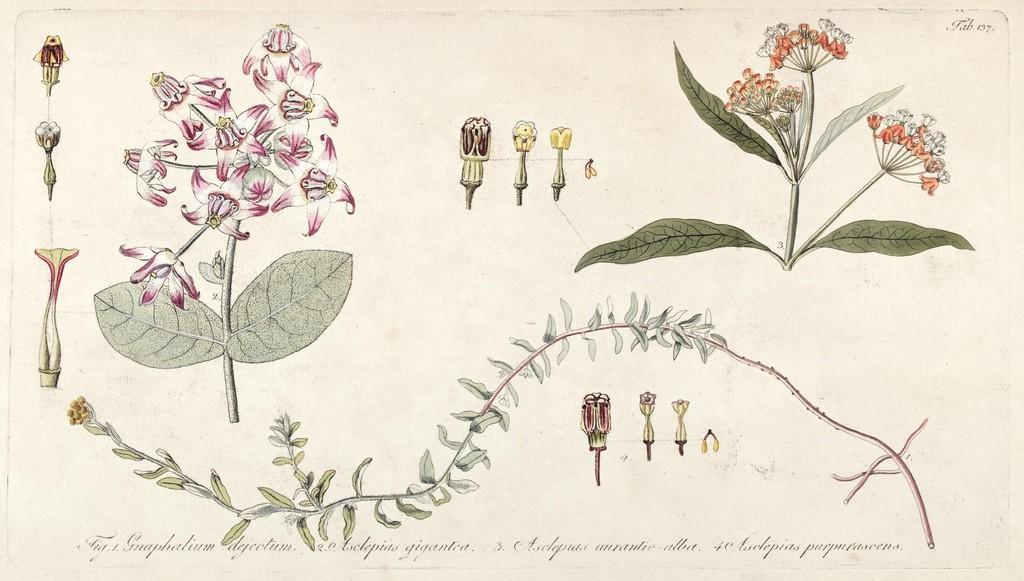Please provide a concise description of this image. In the picture I can see the art of flowers to the plant and its parts. Here I can see some edited text at the bottom of the image. 